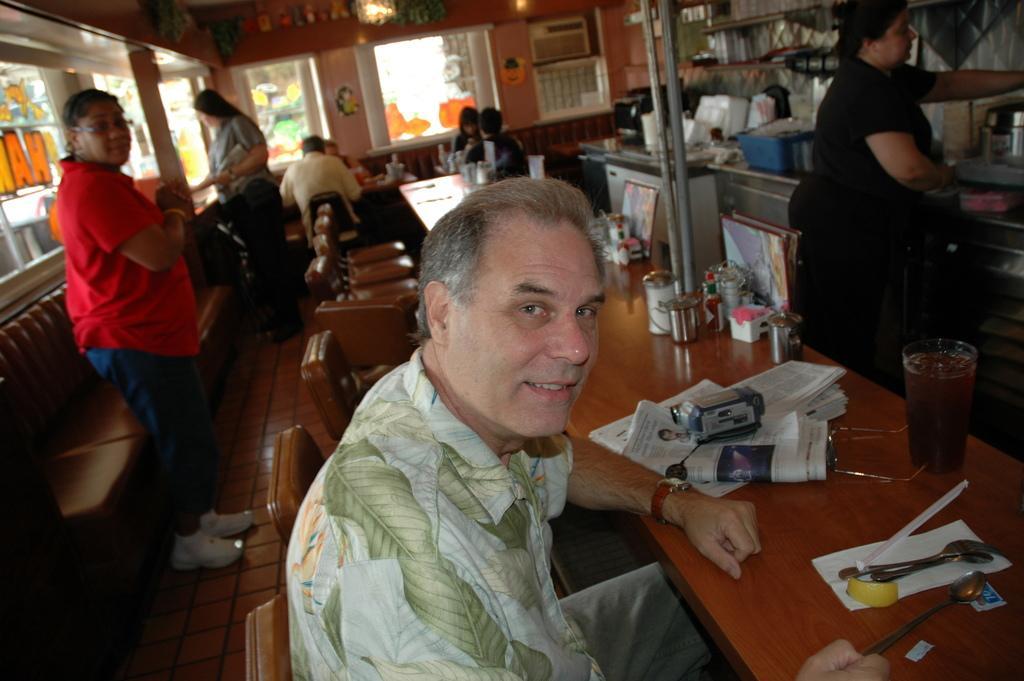How would you summarize this image in a sentence or two? This is an inside view picture. Here we can see a man sitting on a chair in front of a table and on the table we can see spoons, glass with a drink in, newspapers. We can see persons standing here. This is a door. Through window glass outside view is visible. 